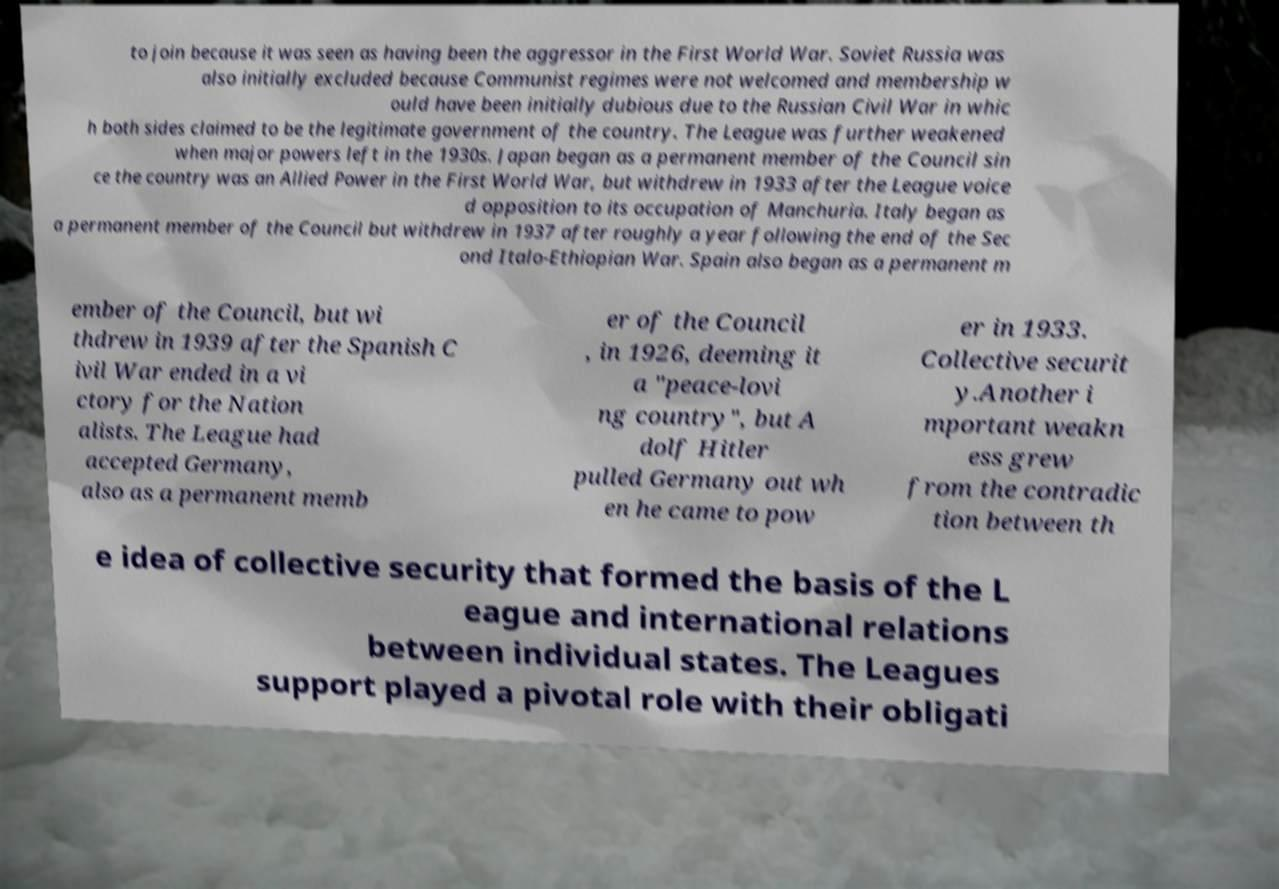There's text embedded in this image that I need extracted. Can you transcribe it verbatim? to join because it was seen as having been the aggressor in the First World War. Soviet Russia was also initially excluded because Communist regimes were not welcomed and membership w ould have been initially dubious due to the Russian Civil War in whic h both sides claimed to be the legitimate government of the country. The League was further weakened when major powers left in the 1930s. Japan began as a permanent member of the Council sin ce the country was an Allied Power in the First World War, but withdrew in 1933 after the League voice d opposition to its occupation of Manchuria. Italy began as a permanent member of the Council but withdrew in 1937 after roughly a year following the end of the Sec ond Italo-Ethiopian War. Spain also began as a permanent m ember of the Council, but wi thdrew in 1939 after the Spanish C ivil War ended in a vi ctory for the Nation alists. The League had accepted Germany, also as a permanent memb er of the Council , in 1926, deeming it a "peace-lovi ng country", but A dolf Hitler pulled Germany out wh en he came to pow er in 1933. Collective securit y.Another i mportant weakn ess grew from the contradic tion between th e idea of collective security that formed the basis of the L eague and international relations between individual states. The Leagues support played a pivotal role with their obligati 